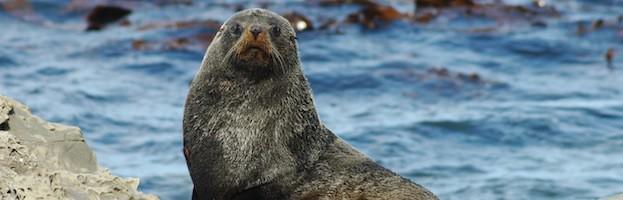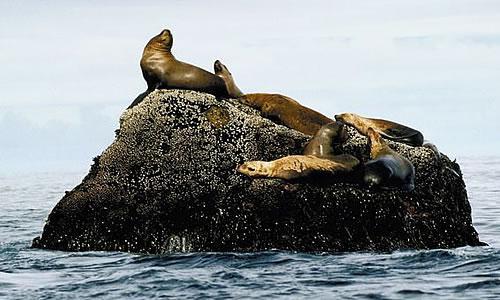The first image is the image on the left, the second image is the image on the right. Considering the images on both sides, is "A seal's body is submerged in water up to its neck in one of the images." valid? Answer yes or no. No. The first image is the image on the left, the second image is the image on the right. Considering the images on both sides, is "The mouth of the seal in one of the images is open." valid? Answer yes or no. No. 